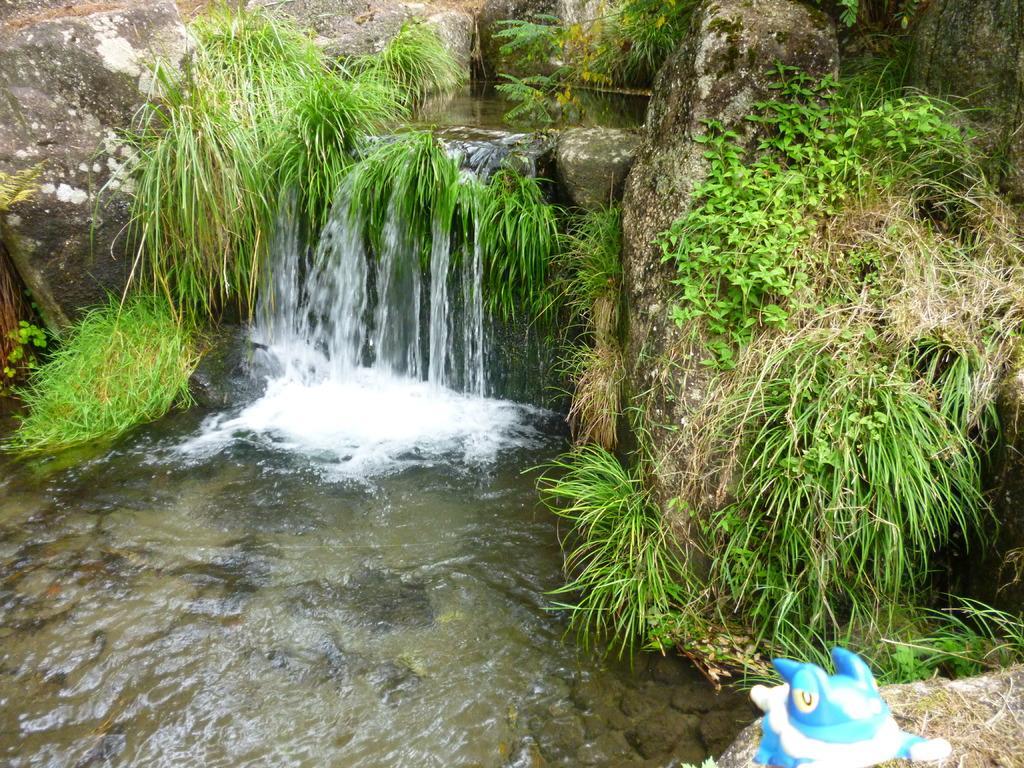In one or two sentences, can you explain what this image depicts? At the bottom right side of the image, there is a toy, which is in blue and white color. In the background we can see grass, stones and water. 